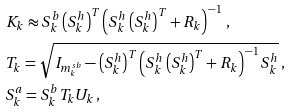<formula> <loc_0><loc_0><loc_500><loc_500>& K _ { k } \approx S _ { k } ^ { b } \left ( S _ { k } ^ { h } \right ) ^ { T } \left ( S _ { k } ^ { h } \left ( S _ { k } ^ { h } \right ) ^ { T } + R _ { k } \right ) ^ { - 1 } \, , \\ & T _ { k } = \sqrt { I _ { m _ { k } ^ { s b } } - \left ( S _ { k } ^ { h } \right ) ^ { T } \left ( S _ { k } ^ { h } \left ( S _ { k } ^ { h } \right ) ^ { T } + R _ { k } \right ) ^ { - 1 } S _ { k } ^ { h } } \, , \\ & S _ { k } ^ { a } = S _ { k } ^ { b } T _ { k } U _ { k } \, ,</formula> 